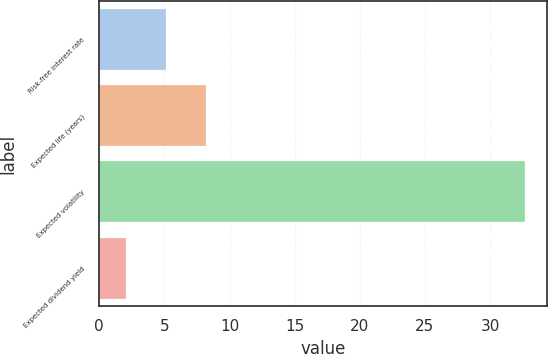<chart> <loc_0><loc_0><loc_500><loc_500><bar_chart><fcel>Risk-free interest rate<fcel>Expected life (years)<fcel>Expected volatility<fcel>Expected dividend yield<nl><fcel>5.15<fcel>8.21<fcel>32.7<fcel>2.09<nl></chart> 